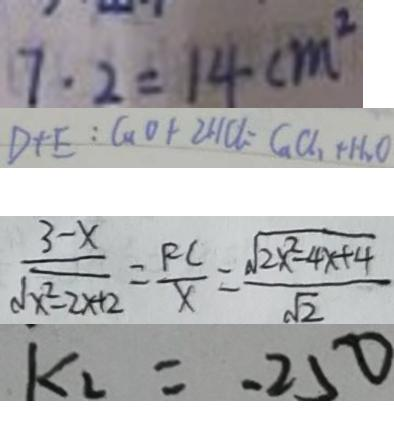<formula> <loc_0><loc_0><loc_500><loc_500>7 \cdot 2 = 1 4 c m ^ { 2 } 
 D + E : C u O + 2 H C l = G a C l _ { 2 } + H _ { 2 } O 
 \frac { 3 - x } { \sqrt { x ^ { 2 } - 2 x + 2 } } = \frac { R C } { x } = \frac { \sqrt { 2 x ^ { 2 } - 4 x + 4 } } { \sqrt { 2 } } 
 k _ { 2 } = - 2 5 0</formula> 